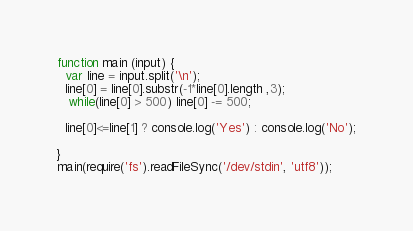Convert code to text. <code><loc_0><loc_0><loc_500><loc_500><_JavaScript_>function main (input) {
  var line = input.split('\n');  
  line[0] = line[0].substr(-1*line[0].length ,3);
   while(line[0] > 500) line[0] -= 500;

  line[0]<=line[1] ? console.log('Yes') : console.log('No');

}
main(require('fs').readFileSync('/dev/stdin', 'utf8'));</code> 